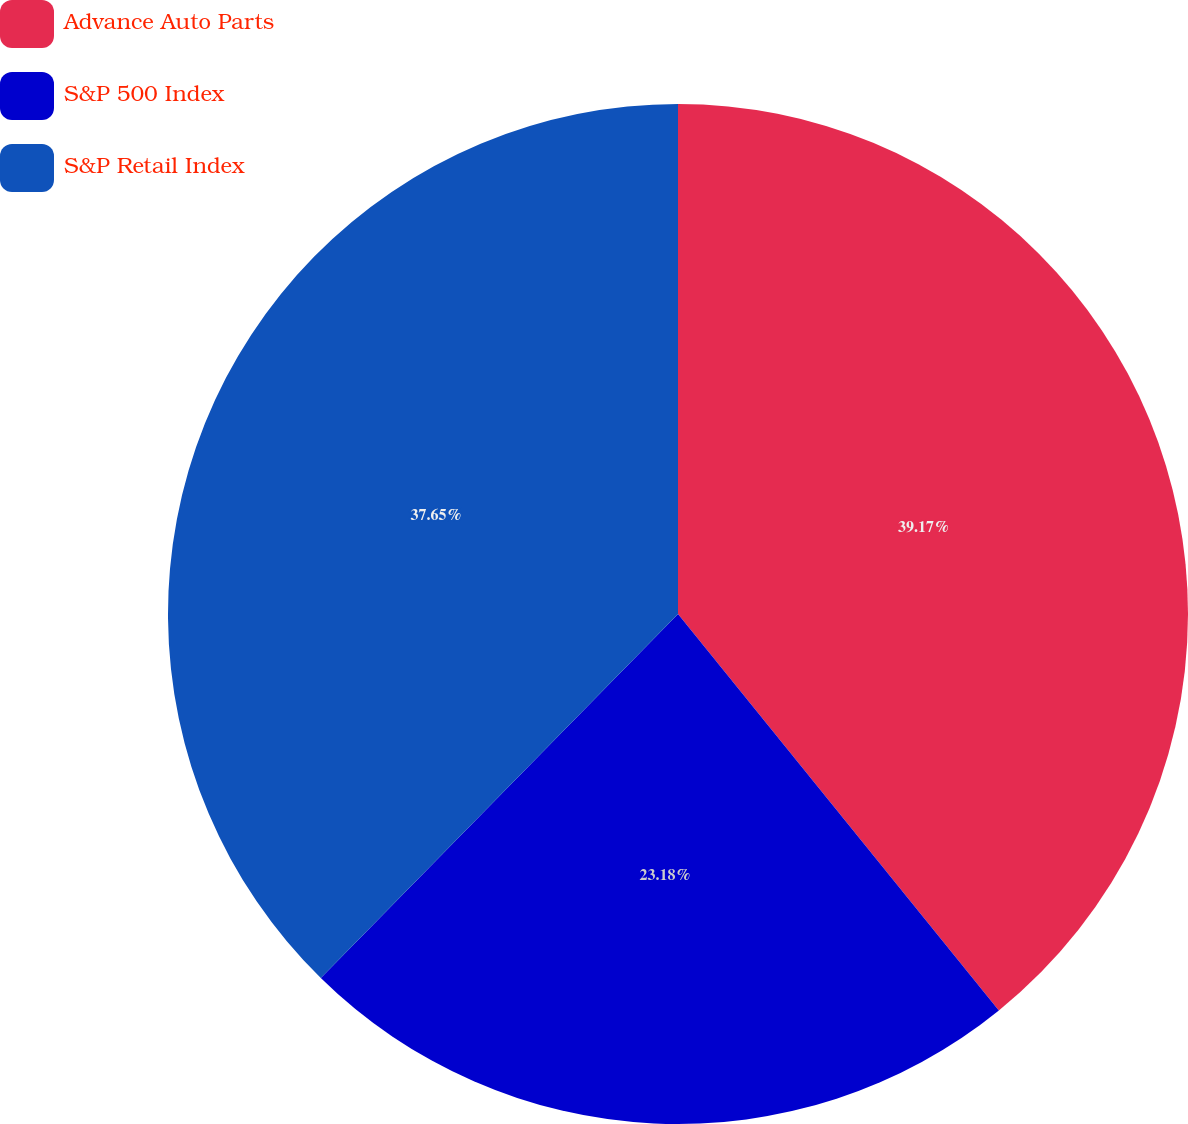Convert chart to OTSL. <chart><loc_0><loc_0><loc_500><loc_500><pie_chart><fcel>Advance Auto Parts<fcel>S&P 500 Index<fcel>S&P Retail Index<nl><fcel>39.17%<fcel>23.18%<fcel>37.65%<nl></chart> 